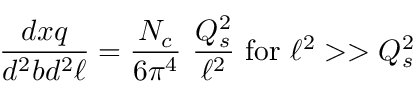Convert formula to latex. <formula><loc_0><loc_0><loc_500><loc_500>{ \frac { d x q } { d ^ { 2 } b d ^ { 2 } \ell } } = { \frac { N _ { c } } { 6 \pi ^ { 4 } } } \ { \frac { Q _ { s } ^ { 2 } } { \ell ^ { 2 } } } \ f o r \ \ell ^ { 2 } > > Q _ { s } ^ { 2 }</formula> 